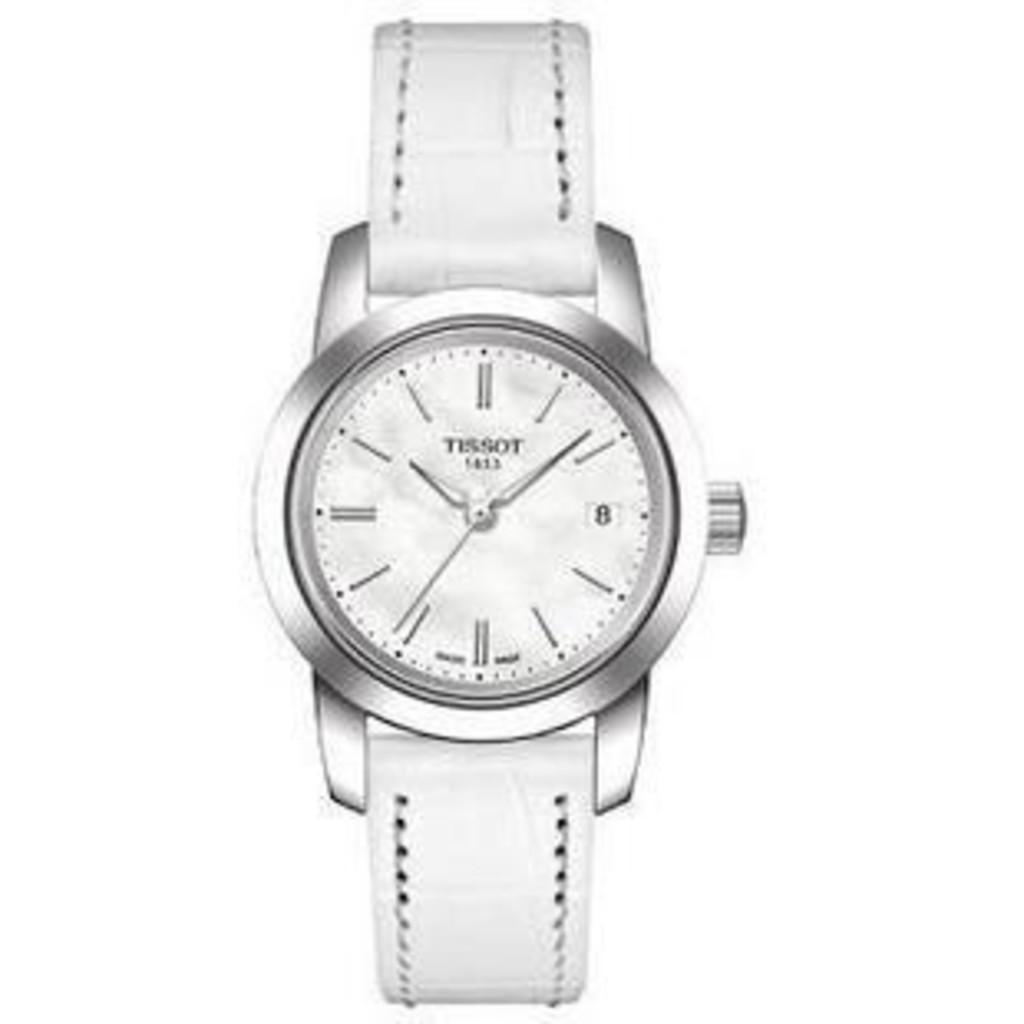What time is shown on the watch?
Your answer should be very brief. 10:08. What brand is the watch?
Give a very brief answer. Tissot. 